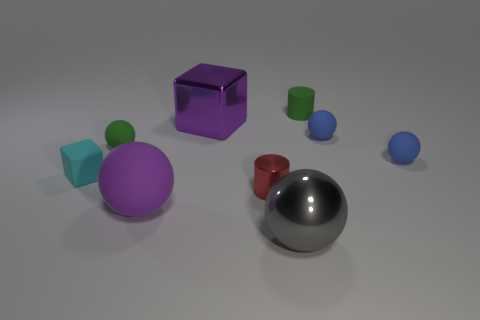What number of tiny matte things have the same shape as the big purple metal object?
Make the answer very short. 1. Do the green thing that is left of the small shiny cylinder and the cyan block have the same material?
Your answer should be very brief. Yes. What number of spheres are either large purple metal things or cyan objects?
Provide a short and direct response. 0. There is a green matte thing to the right of the large metal sphere that is right of the purple object that is behind the red metallic thing; what is its shape?
Your answer should be very brief. Cylinder. There is a object that is the same color as the matte cylinder; what is its shape?
Offer a very short reply. Sphere. What number of purple rubber objects are the same size as the purple metallic thing?
Make the answer very short. 1. There is a metallic thing behind the red metal object; is there a tiny green matte sphere to the right of it?
Offer a terse response. No. How many things are either gray rubber things or purple metallic blocks?
Your answer should be compact. 1. There is a cube that is to the left of the large purple object in front of the cube behind the tiny cyan block; what is its color?
Provide a short and direct response. Cyan. Is there anything else of the same color as the large matte ball?
Offer a very short reply. Yes. 